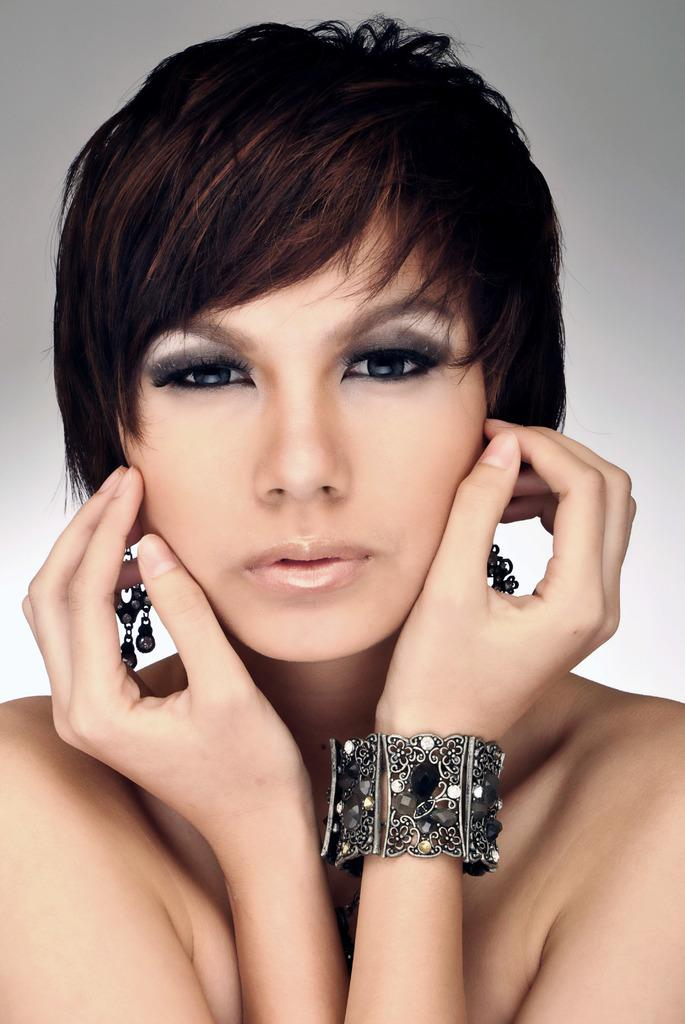Who is present in the image? There is a woman in the image. What is the woman wearing? The woman is wearing jewelry. What type of plant is growing in the woman's hair in the image? There is no plant visible in the woman's hair in the image. 